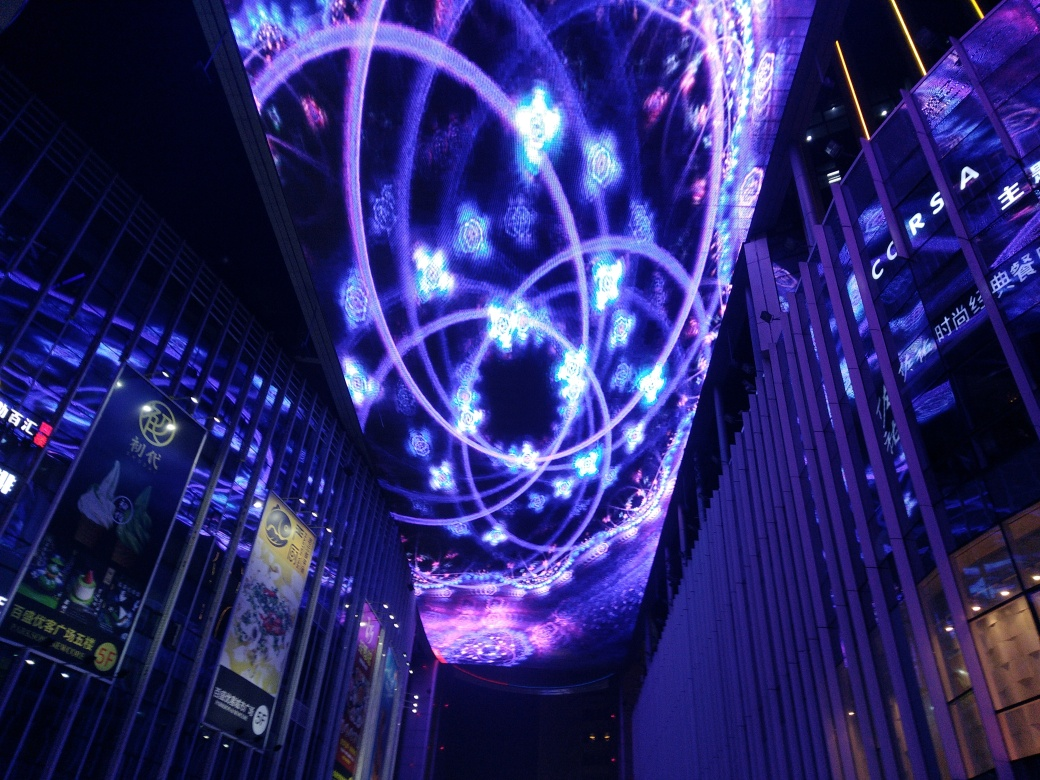What kind of event or location does this image suggest? The vibrant light display with intricate patterns hints at a modern, possibly urban setting, likely a public space or entertainment venue. The digital artistry suggests either a cultural event, a digital exhibition, or a permanent installation designed to attract attention and provide a visually stimulating experience. 